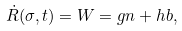Convert formula to latex. <formula><loc_0><loc_0><loc_500><loc_500>\dot { R } ( \sigma , t ) = W = g n + h b ,</formula> 